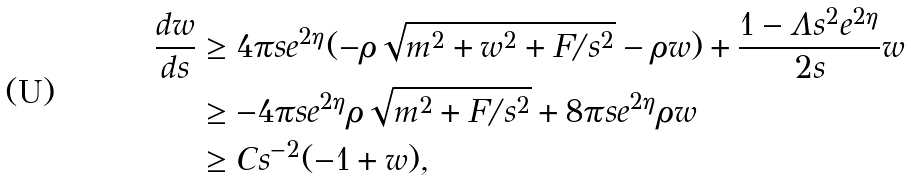<formula> <loc_0><loc_0><loc_500><loc_500>\frac { d w } { d s } & \geq 4 \pi s e ^ { 2 \eta } ( - \rho \sqrt { m ^ { 2 } + w ^ { 2 } + F / s ^ { 2 } } - \rho w ) + \frac { 1 - \Lambda s ^ { 2 } e ^ { 2 \eta } } { 2 s } w \\ & \geq - 4 \pi s e ^ { 2 \eta } \rho \sqrt { m ^ { 2 } + F / s ^ { 2 } } + 8 \pi s e ^ { 2 \eta } \rho w \\ & \geq C s ^ { - 2 } ( - 1 + w ) ,</formula> 